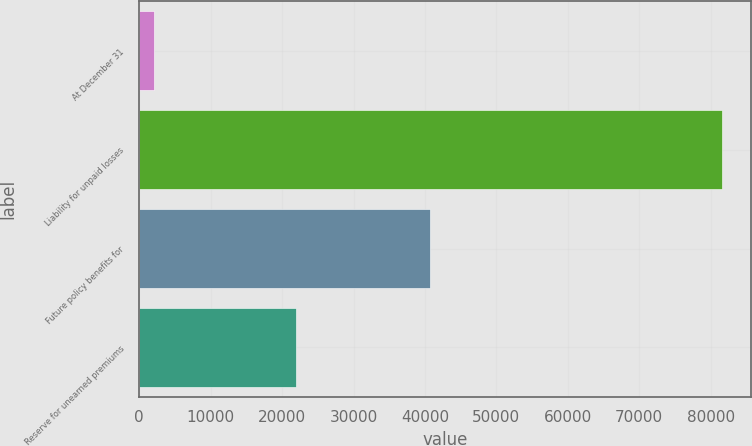<chart> <loc_0><loc_0><loc_500><loc_500><bar_chart><fcel>At December 31<fcel>Liability for unpaid losses<fcel>Future policy benefits for<fcel>Reserve for unearned premiums<nl><fcel>2013<fcel>81547<fcel>40653<fcel>21953<nl></chart> 